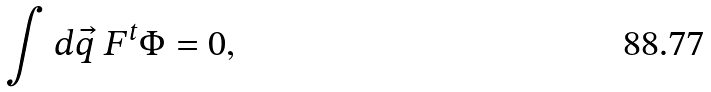<formula> <loc_0><loc_0><loc_500><loc_500>\int d \vec { q } \ F ^ { t } \Phi = 0 ,</formula> 